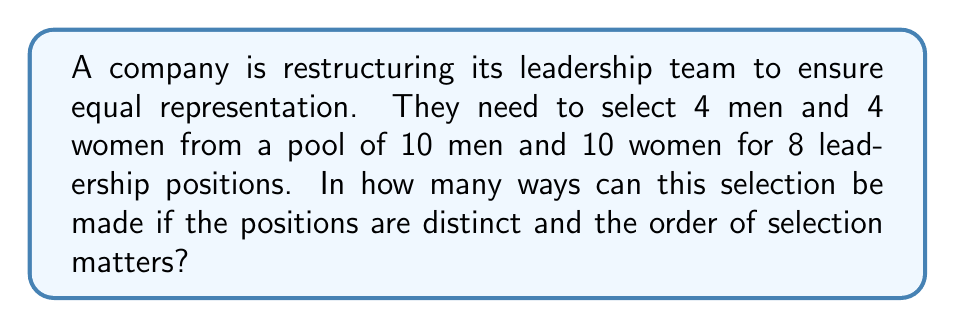Help me with this question. Let's approach this step-by-step:

1) First, we need to select 4 men out of 10. This can be done in $\binom{10}{4}$ ways.

2) Then, we need to select 4 women out of 10. This can also be done in $\binom{10}{4}$ ways.

3) After selecting the individuals, we need to arrange them in the 8 distinct positions. This is a permutation of 8 people, which can be done in 8! ways.

4) By the multiplication principle, the total number of ways to select and arrange the leadership team is:

   $$\binom{10}{4} \cdot \binom{10}{4} \cdot 8!$$

5) Let's calculate each part:
   
   $\binom{10}{4} = \frac{10!}{4!(10-4)!} = \frac{10!}{4!6!} = 210$
   
   $8! = 40,320$

6) Putting it all together:

   $210 \cdot 210 \cdot 40,320 = 1,776,600,000$

Thus, there are 1,776,600,000 ways to select and arrange the leadership team ensuring equal representation.
Answer: 1,776,600,000 